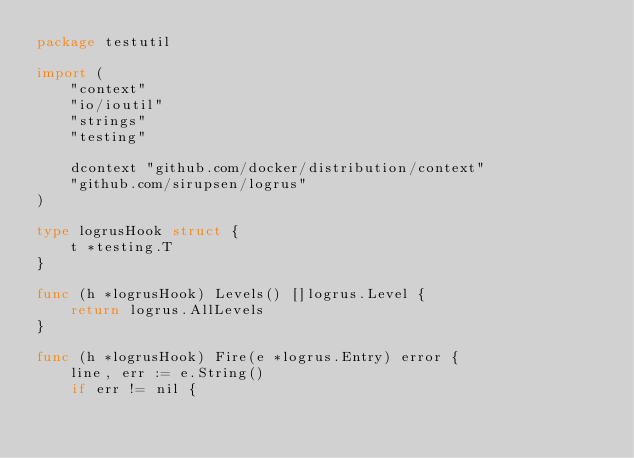<code> <loc_0><loc_0><loc_500><loc_500><_Go_>package testutil

import (
	"context"
	"io/ioutil"
	"strings"
	"testing"

	dcontext "github.com/docker/distribution/context"
	"github.com/sirupsen/logrus"
)

type logrusHook struct {
	t *testing.T
}

func (h *logrusHook) Levels() []logrus.Level {
	return logrus.AllLevels
}

func (h *logrusHook) Fire(e *logrus.Entry) error {
	line, err := e.String()
	if err != nil {</code> 